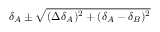<formula> <loc_0><loc_0><loc_500><loc_500>\delta _ { A } \pm \sqrt { ( \Delta \delta _ { A } ) ^ { 2 } + ( \delta _ { A } - \delta _ { B } ) ^ { 2 } }</formula> 